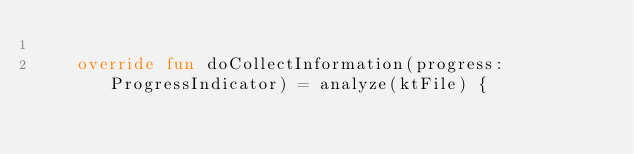<code> <loc_0><loc_0><loc_500><loc_500><_Kotlin_>
    override fun doCollectInformation(progress: ProgressIndicator) = analyze(ktFile) {</code> 